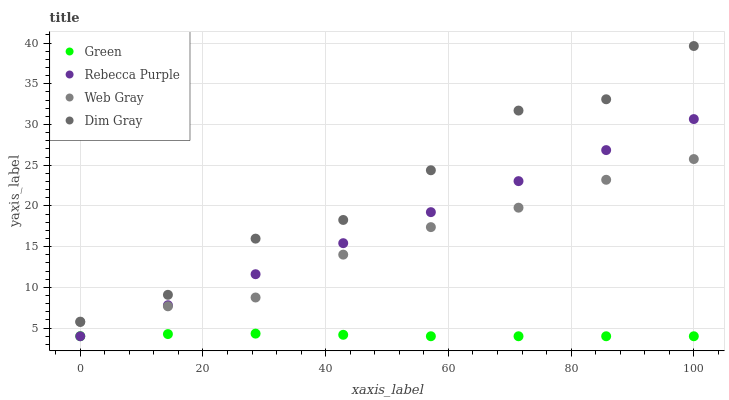Does Green have the minimum area under the curve?
Answer yes or no. Yes. Does Dim Gray have the maximum area under the curve?
Answer yes or no. Yes. Does Web Gray have the minimum area under the curve?
Answer yes or no. No. Does Web Gray have the maximum area under the curve?
Answer yes or no. No. Is Rebecca Purple the smoothest?
Answer yes or no. Yes. Is Dim Gray the roughest?
Answer yes or no. Yes. Is Web Gray the smoothest?
Answer yes or no. No. Is Web Gray the roughest?
Answer yes or no. No. Does Green have the lowest value?
Answer yes or no. Yes. Does Web Gray have the lowest value?
Answer yes or no. No. Does Dim Gray have the highest value?
Answer yes or no. Yes. Does Web Gray have the highest value?
Answer yes or no. No. Is Green less than Web Gray?
Answer yes or no. Yes. Is Dim Gray greater than Green?
Answer yes or no. Yes. Does Rebecca Purple intersect Web Gray?
Answer yes or no. Yes. Is Rebecca Purple less than Web Gray?
Answer yes or no. No. Is Rebecca Purple greater than Web Gray?
Answer yes or no. No. Does Green intersect Web Gray?
Answer yes or no. No. 